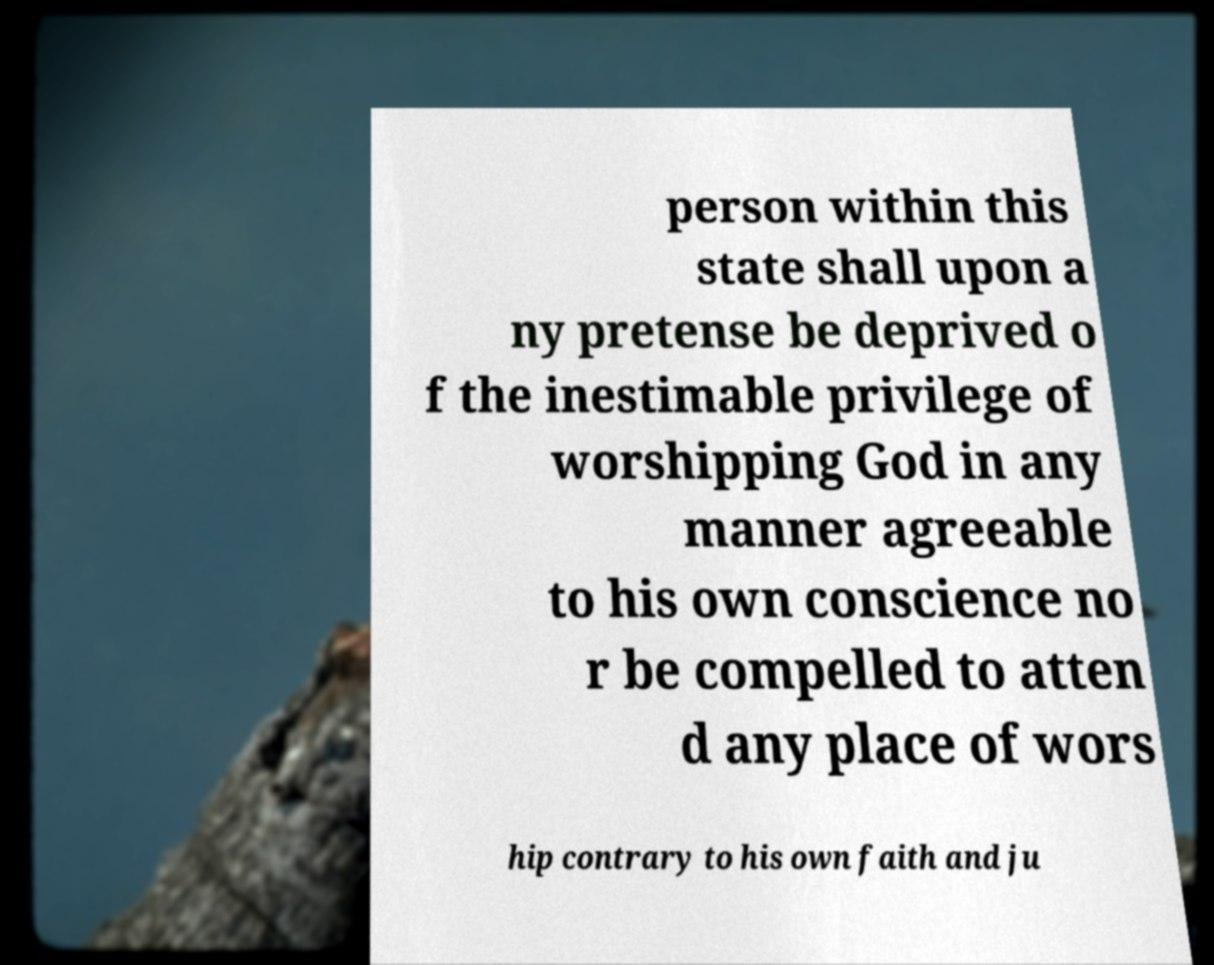Can you read and provide the text displayed in the image?This photo seems to have some interesting text. Can you extract and type it out for me? person within this state shall upon a ny pretense be deprived o f the inestimable privilege of worshipping God in any manner agreeable to his own conscience no r be compelled to atten d any place of wors hip contrary to his own faith and ju 